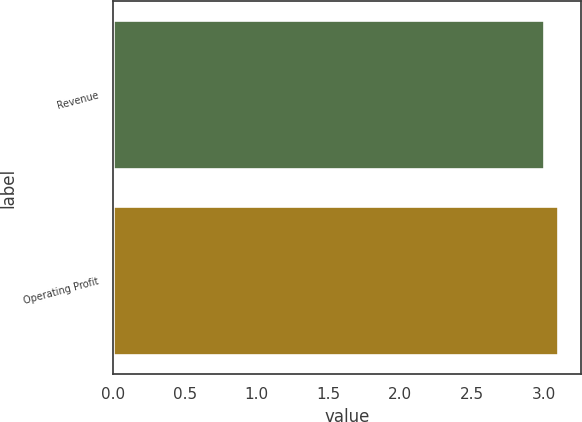Convert chart. <chart><loc_0><loc_0><loc_500><loc_500><bar_chart><fcel>Revenue<fcel>Operating Profit<nl><fcel>3<fcel>3.1<nl></chart> 